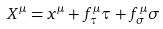Convert formula to latex. <formula><loc_0><loc_0><loc_500><loc_500>X ^ { \mu } = x ^ { \mu } + f _ { \tau } ^ { \mu } \tau + f _ { \sigma } ^ { \mu } \sigma</formula> 